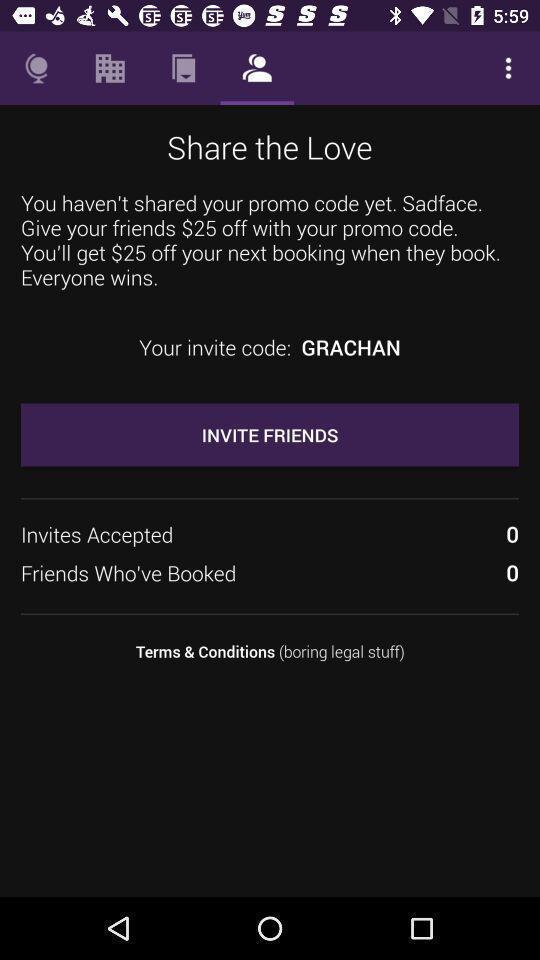Describe this image in words. Page shows to invite your friends. 